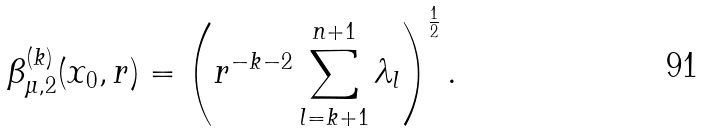<formula> <loc_0><loc_0><loc_500><loc_500>\beta ^ { ( k ) } _ { \mu , 2 } ( x _ { 0 } , r ) = \left ( r ^ { - k - 2 } \sum _ { l = k + 1 } ^ { n + 1 } \lambda _ { l } \right ) ^ { \frac { 1 } { 2 } } .</formula> 